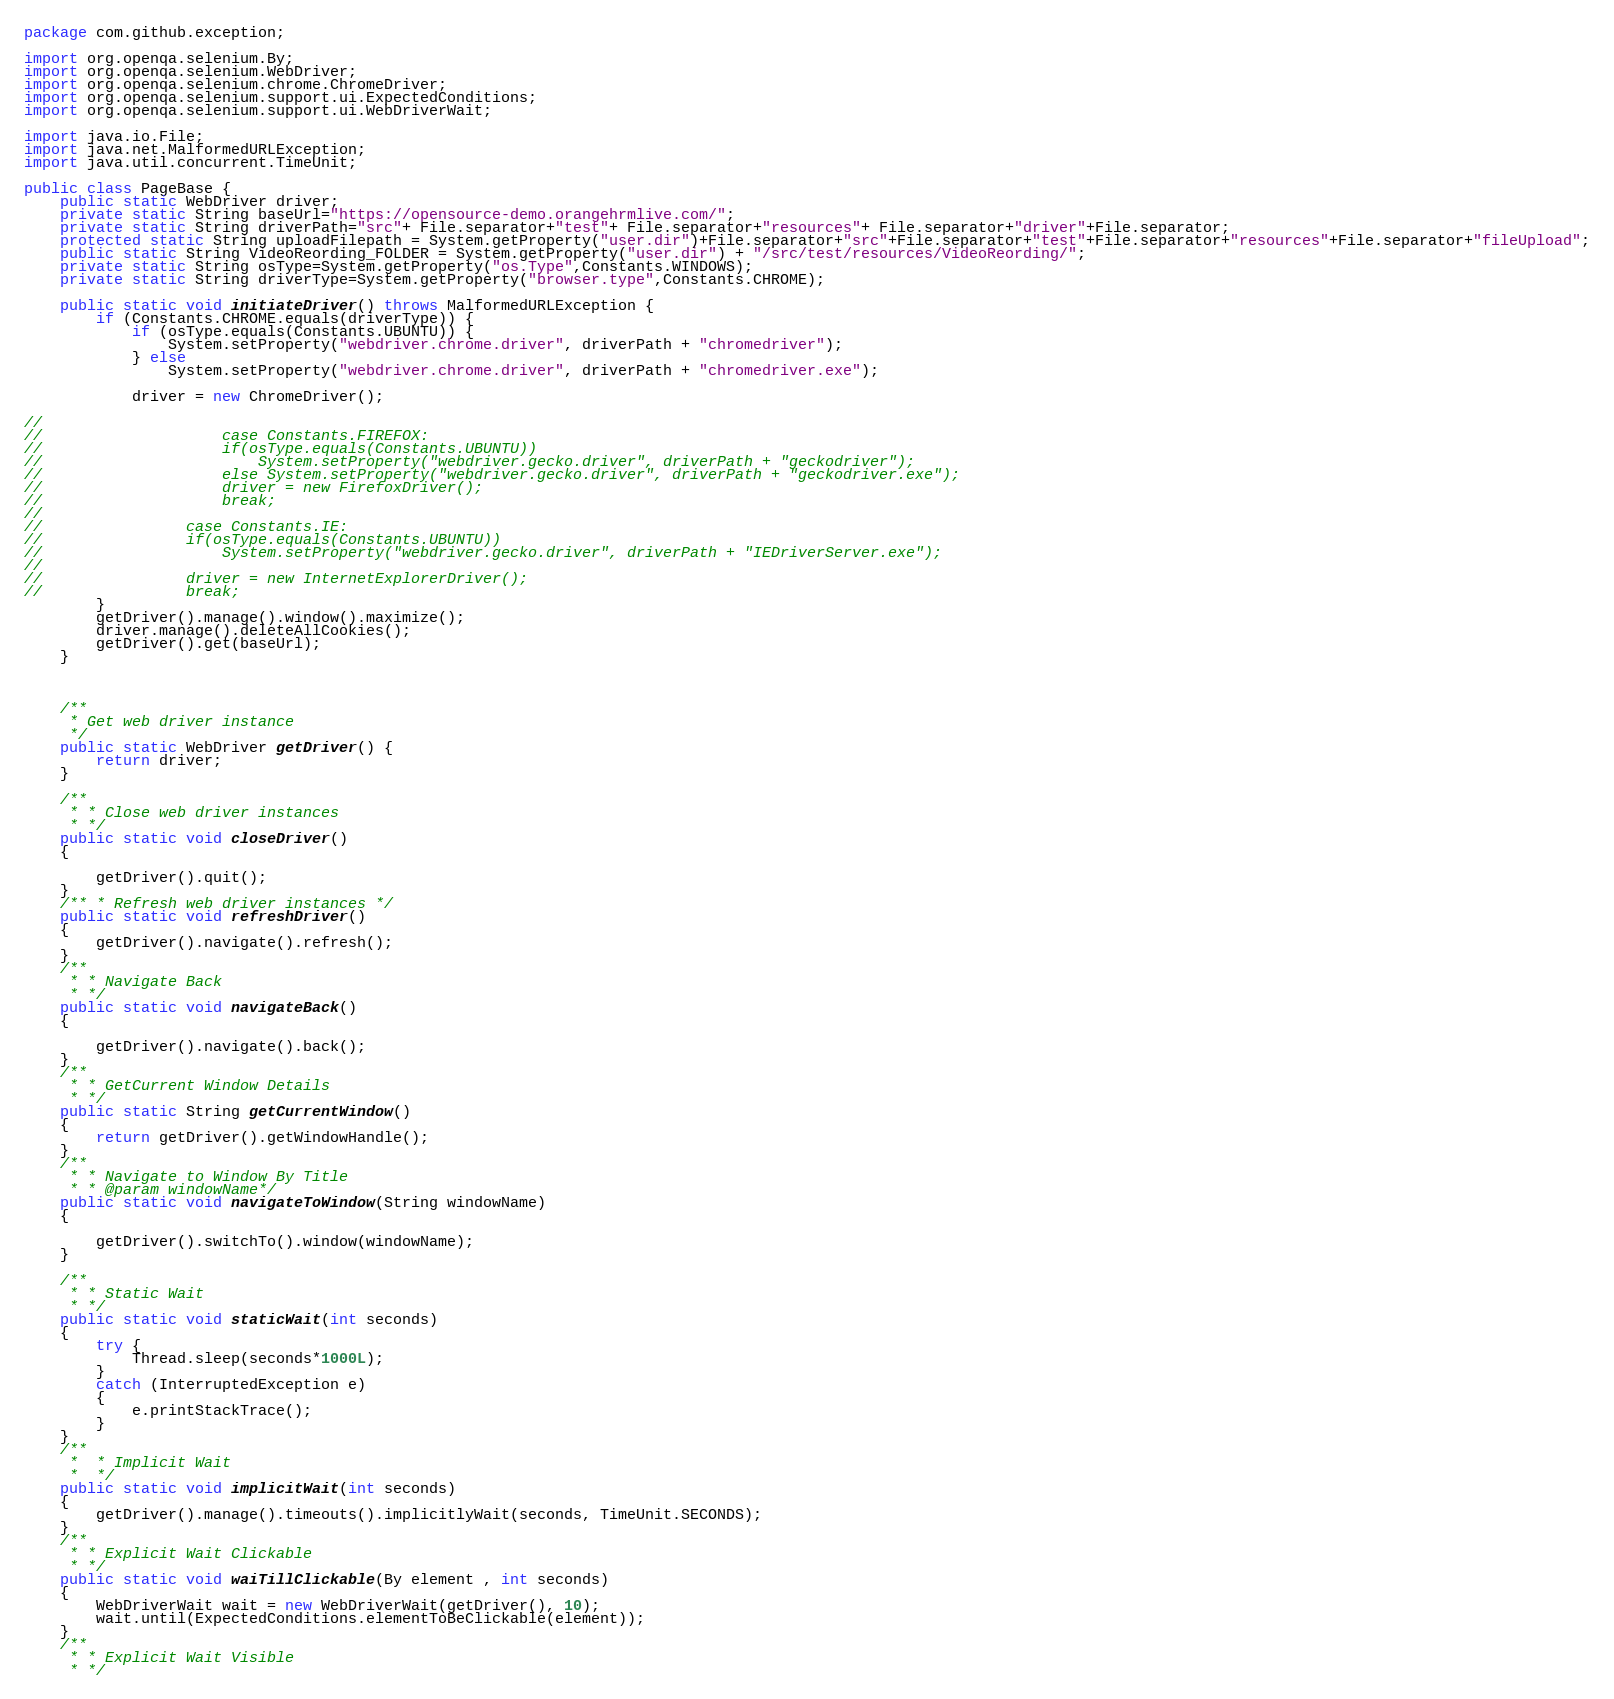<code> <loc_0><loc_0><loc_500><loc_500><_Java_>package com.github.exception;

import org.openqa.selenium.By;
import org.openqa.selenium.WebDriver;
import org.openqa.selenium.chrome.ChromeDriver;
import org.openqa.selenium.support.ui.ExpectedConditions;
import org.openqa.selenium.support.ui.WebDriverWait;

import java.io.File;
import java.net.MalformedURLException;
import java.util.concurrent.TimeUnit;

public class PageBase {
    public static WebDriver driver;
    private static String baseUrl="https://opensource-demo.orangehrmlive.com/";
    private static String driverPath="src"+ File.separator+"test"+ File.separator+"resources"+ File.separator+"driver"+File.separator;
    protected static String uploadFilepath = System.getProperty("user.dir")+File.separator+"src"+File.separator+"test"+File.separator+"resources"+File.separator+"fileUpload";
    public static String VideoReording_FOLDER = System.getProperty("user.dir") + "/src/test/resources/VideoReording/";
    private static String osType=System.getProperty("os.Type",Constants.WINDOWS);
    private static String driverType=System.getProperty("browser.type",Constants.CHROME);

    public static void initiateDriver() throws MalformedURLException {
        if (Constants.CHROME.equals(driverType)) {
            if (osType.equals(Constants.UBUNTU)) {
                System.setProperty("webdriver.chrome.driver", driverPath + "chromedriver");
            } else
                System.setProperty("webdriver.chrome.driver", driverPath + "chromedriver.exe");

            driver = new ChromeDriver();

//
//                    case Constants.FIREFOX:
//                    if(osType.equals(Constants.UBUNTU))
//                        System.setProperty("webdriver.gecko.driver", driverPath + "geckodriver");
//                    else System.setProperty("webdriver.gecko.driver", driverPath + "geckodriver.exe");
//                    driver = new FirefoxDriver();
//                    break;
//
//                case Constants.IE:
//                if(osType.equals(Constants.UBUNTU))
//                    System.setProperty("webdriver.gecko.driver", driverPath + "IEDriverServer.exe");
//
//                driver = new InternetExplorerDriver();
//                break;
        }
        getDriver().manage().window().maximize();
        driver.manage().deleteAllCookies();
        getDriver().get(baseUrl);
    }



    /**
     * Get web driver instance
     */
    public static WebDriver getDriver() {
        return driver;
    }

    /**
     * * Close web driver instances
     * */
    public static void closeDriver()
    {

        getDriver().quit();
    }
    /** * Refresh web driver instances */
    public static void refreshDriver()
    {
        getDriver().navigate().refresh();
    }
    /**
     * * Navigate Back
     * */
    public static void navigateBack()
    {

        getDriver().navigate().back();
    }
    /**
     * * GetCurrent Window Details
     * */
    public static String getCurrentWindow()
    {
        return getDriver().getWindowHandle();
    }
    /**
     * * Navigate to Window By Title
     * * @param windowName*/
    public static void navigateToWindow(String windowName)
    {

        getDriver().switchTo().window(windowName);
    }

    /**
     * * Static Wait
     * */
    public static void staticWait(int seconds)
    {
        try {
            Thread.sleep(seconds*1000L);
        }
        catch (InterruptedException e)
        {
            e.printStackTrace();
        }
    }
    /**
     *  * Implicit Wait
     *  */
    public static void implicitWait(int seconds)
    {
        getDriver().manage().timeouts().implicitlyWait(seconds, TimeUnit.SECONDS);
    }
    /**
     * * Explicit Wait Clickable
     * */
    public static void waiTillClickable(By element , int seconds)
    {
        WebDriverWait wait = new WebDriverWait(getDriver(), 10);
        wait.until(ExpectedConditions.elementToBeClickable(element));
    }
    /**
     * * Explicit Wait Visible
     * */</code> 